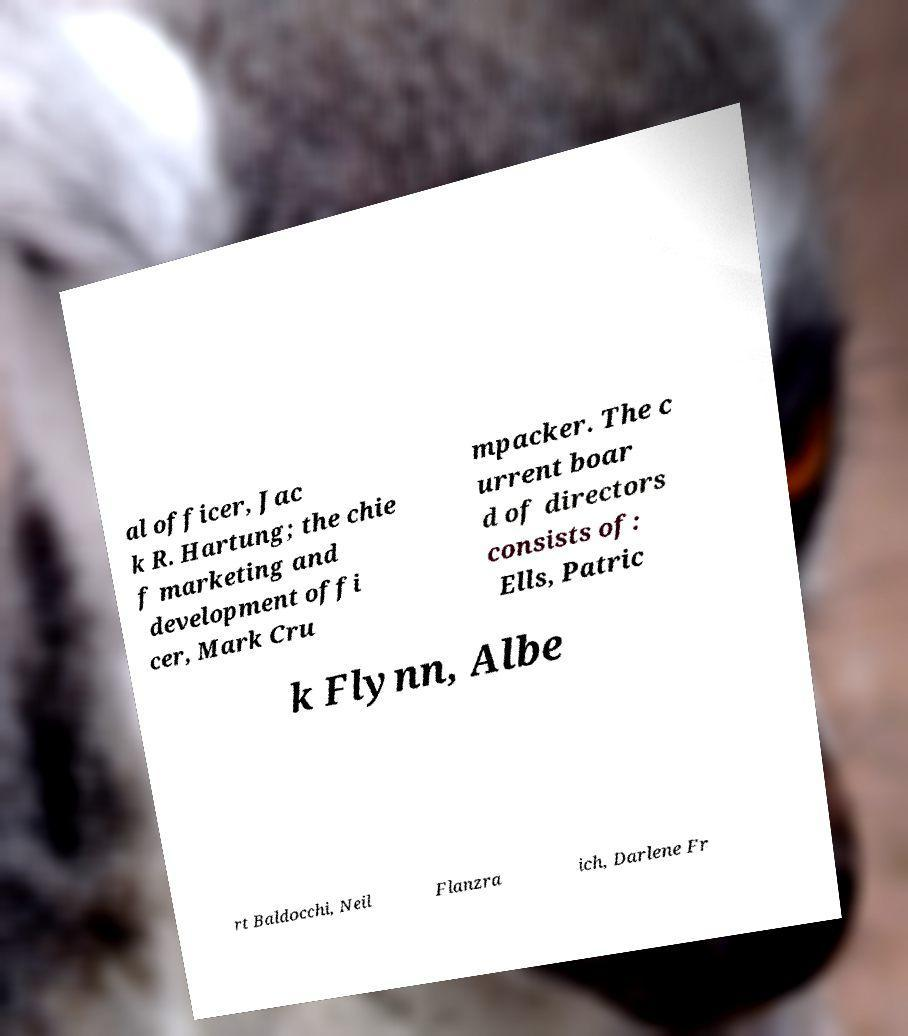Please identify and transcribe the text found in this image. al officer, Jac k R. Hartung; the chie f marketing and development offi cer, Mark Cru mpacker. The c urrent boar d of directors consists of: Ells, Patric k Flynn, Albe rt Baldocchi, Neil Flanzra ich, Darlene Fr 